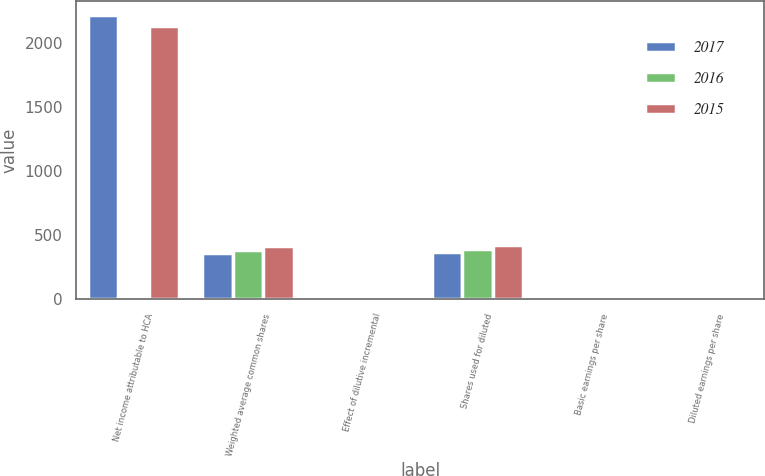Convert chart. <chart><loc_0><loc_0><loc_500><loc_500><stacked_bar_chart><ecel><fcel>Net income attributable to HCA<fcel>Weighted average common shares<fcel>Effect of dilutive incremental<fcel>Shares used for diluted<fcel>Basic earnings per share<fcel>Diluted earnings per share<nl><fcel>2017<fcel>2216<fcel>362.31<fcel>9.92<fcel>372.22<fcel>6.12<fcel>5.95<nl><fcel>2016<fcel>12.53<fcel>383.59<fcel>12.26<fcel>395.85<fcel>7.53<fcel>7.3<nl><fcel>2015<fcel>2129<fcel>414.19<fcel>12.53<fcel>426.72<fcel>5.14<fcel>4.99<nl></chart> 